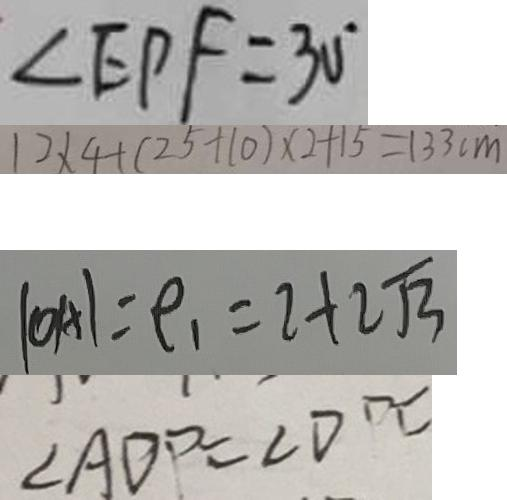Convert formula to latex. <formula><loc_0><loc_0><loc_500><loc_500>\angle E P F = 3 0 ^ { \circ } 
 1 2 \times 4 + ( 2 5 + 1 0 ) \times 2 + 1 5 = 1 3 3 c m 
 \vert O A \vert = \rho _ { 1 } = 2 + 2 \sqrt { 3 } 
 \angle A D P = \angle D P C</formula> 